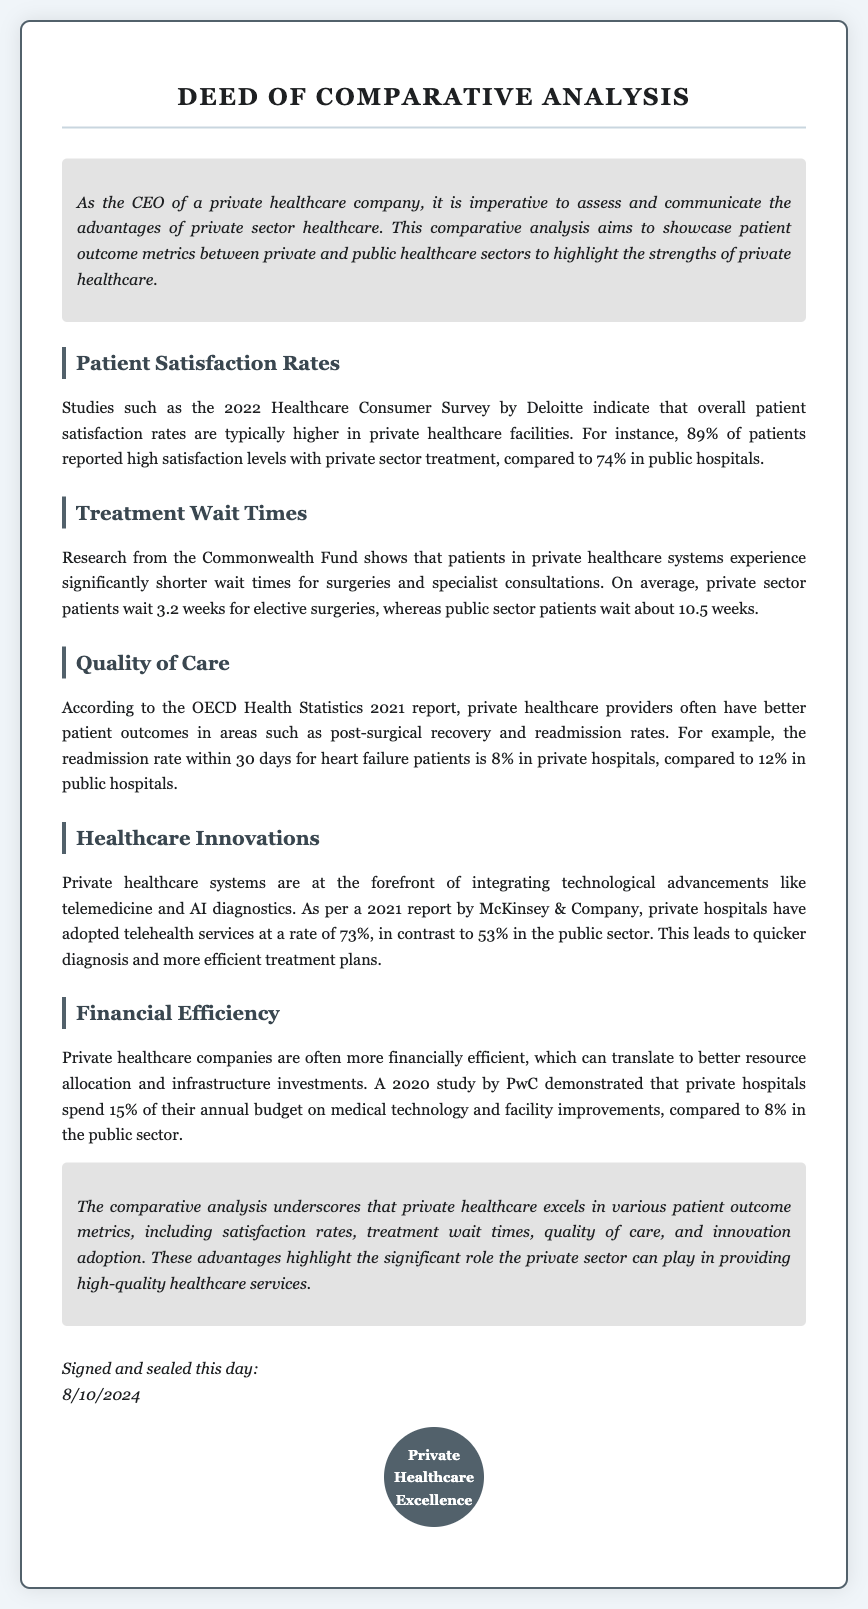What is the patient satisfaction rate in private healthcare? The document states that 89% of patients reported high satisfaction levels with private sector treatment.
Answer: 89% How long do private sector patients wait for elective surgeries? According to the document, private sector patients wait an average of 3.2 weeks for elective surgeries.
Answer: 3.2 weeks What is the readmission rate for heart failure patients in private hospitals? The document mentions that the readmission rate within 30 days for heart failure patients is 8% in private hospitals.
Answer: 8% What percentage of private hospitals have adopted telehealth services? The document indicates that private hospitals have adopted telehealth services at a rate of 73%.
Answer: 73% What is the annual budget percentage spent on medical technology by private hospitals? The document states that private hospitals spend 15% of their annual budget on medical technology and facility improvements.
Answer: 15% In what year did the Healthcare Consumer Survey by Deloitte take place? The document cites the 2022 Healthcare Consumer Survey by Deloitte.
Answer: 2022 Which organization produced the report showing that patients in private healthcare have shorter wait times? The Commonwealth Fund is mentioned as the source of research showing shorter wait times in the private sector.
Answer: Commonwealth Fund What is the primary purpose of this comparative analysis? The primary purpose is to showcase patient outcome metrics between private and public healthcare sectors to highlight the strengths of private healthcare.
Answer: Showcase strengths What does the signature section of the document indicate? The signature section indicates the date the deed is signed and sealed.
Answer: Signing date What type of document is this? The document is classified as a deed of comparative analysis.
Answer: Deed 